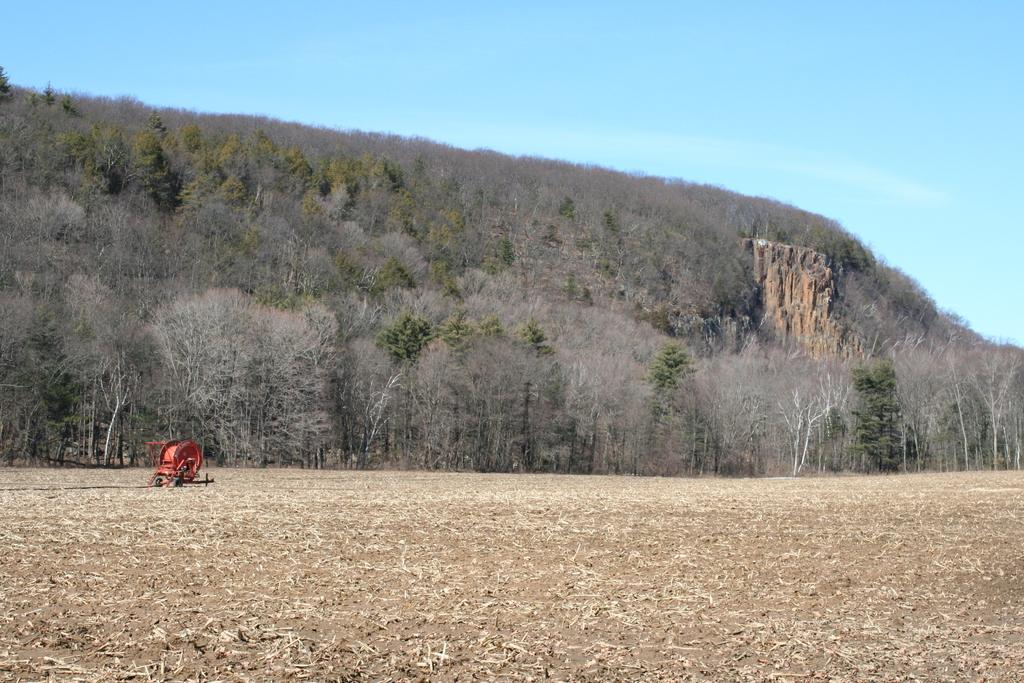What is the color of the object on the ground in the image? The object on the ground is red. What can be seen in the background of the image? There are trees and a rock in the background of the image, as well as the sky. What type of wine is being served in the image? There is no wine present in the image. Who is the owner of the red object in the image? There is no indication of ownership in the image, and the red object is not associated with any person or character. 